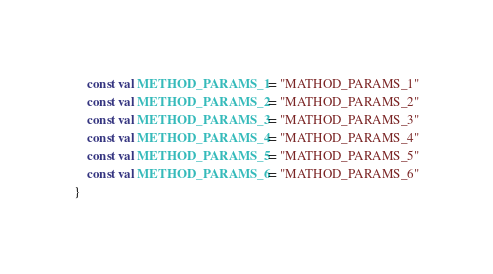<code> <loc_0><loc_0><loc_500><loc_500><_Kotlin_>    const val METHOD_PARAMS_1 = "MATHOD_PARAMS_1"
    const val METHOD_PARAMS_2 = "MATHOD_PARAMS_2"
    const val METHOD_PARAMS_3 = "MATHOD_PARAMS_3"
    const val METHOD_PARAMS_4 = "MATHOD_PARAMS_4"
    const val METHOD_PARAMS_5 = "MATHOD_PARAMS_5"
    const val METHOD_PARAMS_6 = "MATHOD_PARAMS_6"
}</code> 